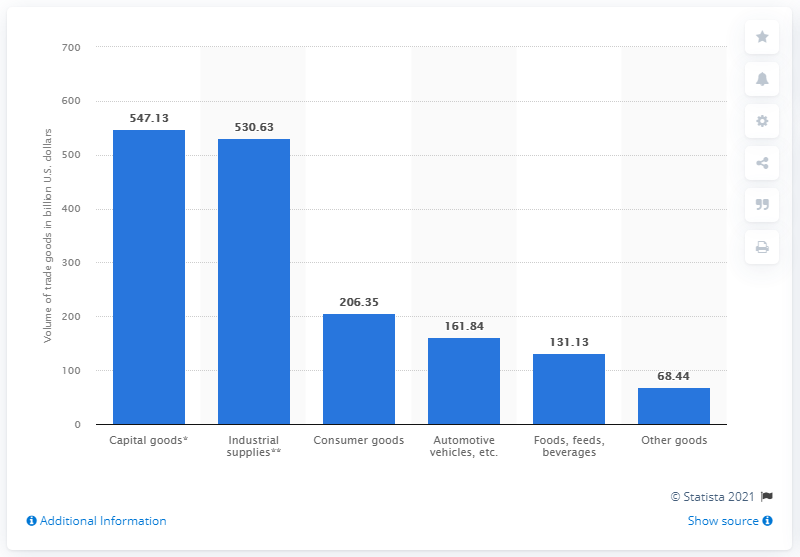Draw attention to some important aspects in this diagram. In 2019, the United States exported $206.35 billion worth of consumer goods. 